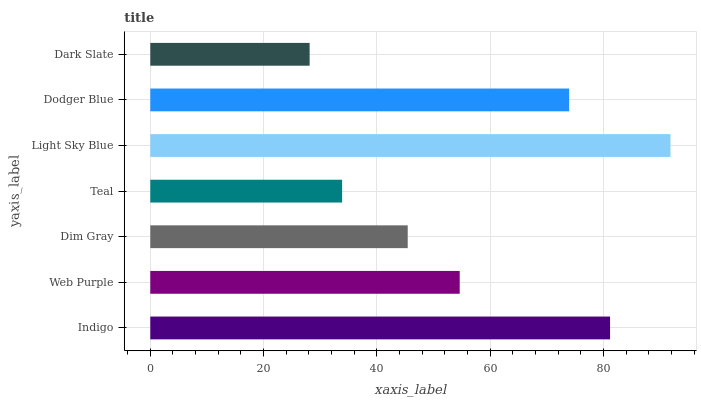Is Dark Slate the minimum?
Answer yes or no. Yes. Is Light Sky Blue the maximum?
Answer yes or no. Yes. Is Web Purple the minimum?
Answer yes or no. No. Is Web Purple the maximum?
Answer yes or no. No. Is Indigo greater than Web Purple?
Answer yes or no. Yes. Is Web Purple less than Indigo?
Answer yes or no. Yes. Is Web Purple greater than Indigo?
Answer yes or no. No. Is Indigo less than Web Purple?
Answer yes or no. No. Is Web Purple the high median?
Answer yes or no. Yes. Is Web Purple the low median?
Answer yes or no. Yes. Is Dodger Blue the high median?
Answer yes or no. No. Is Indigo the low median?
Answer yes or no. No. 